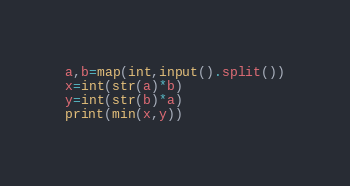Convert code to text. <code><loc_0><loc_0><loc_500><loc_500><_Python_>a,b=map(int,input().split())
x=int(str(a)*b)
y=int(str(b)*a)
print(min(x,y))</code> 